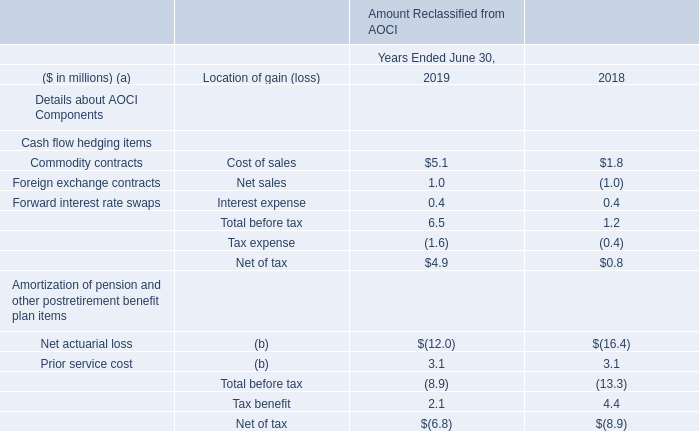The following is a summary of amounts reclassified from AOCI for the years ended June 30, 2019 and 2018:
(a) Amounts in parentheses indicate debits to income/loss.
(b) These AOCI components are included in the computation of net periodic benefit cost (see Note 11 for additional details).
What do the amounts in parentheses in the table indicate? Debits to income/loss. Where are Net actuarial loss and Prior service cost included? In the computation of net periodic benefit cost (see note 11 for additional details). In which years is information on the amounts reclassified from AOCI provided? 2019, 2018. In which year was the amount of tax benefit larger? 4.4>2.1
Answer: 2018. What was the change in Forward interest rate swaps in 2019 from 2018?
Answer scale should be: million. 0.4-0.4
Answer: 0. What was the percentage change in Forward interest rate swaps in 2019 from 2018?
Answer scale should be: percent. (0.4-0.4)/0.4
Answer: 0. 